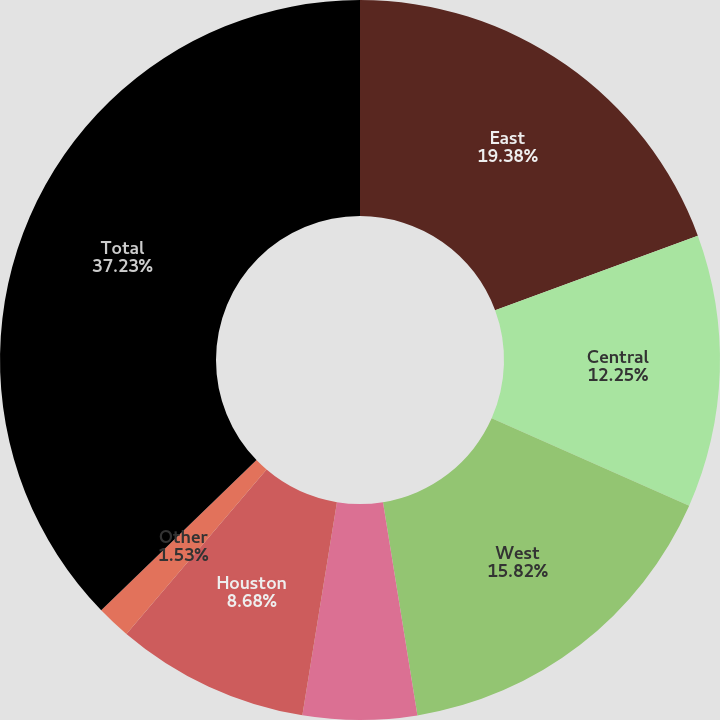Convert chart. <chart><loc_0><loc_0><loc_500><loc_500><pie_chart><fcel>East<fcel>Central<fcel>West<fcel>Southeast Florida<fcel>Houston<fcel>Other<fcel>Total<nl><fcel>19.39%<fcel>12.25%<fcel>15.82%<fcel>5.11%<fcel>8.68%<fcel>1.53%<fcel>37.24%<nl></chart> 